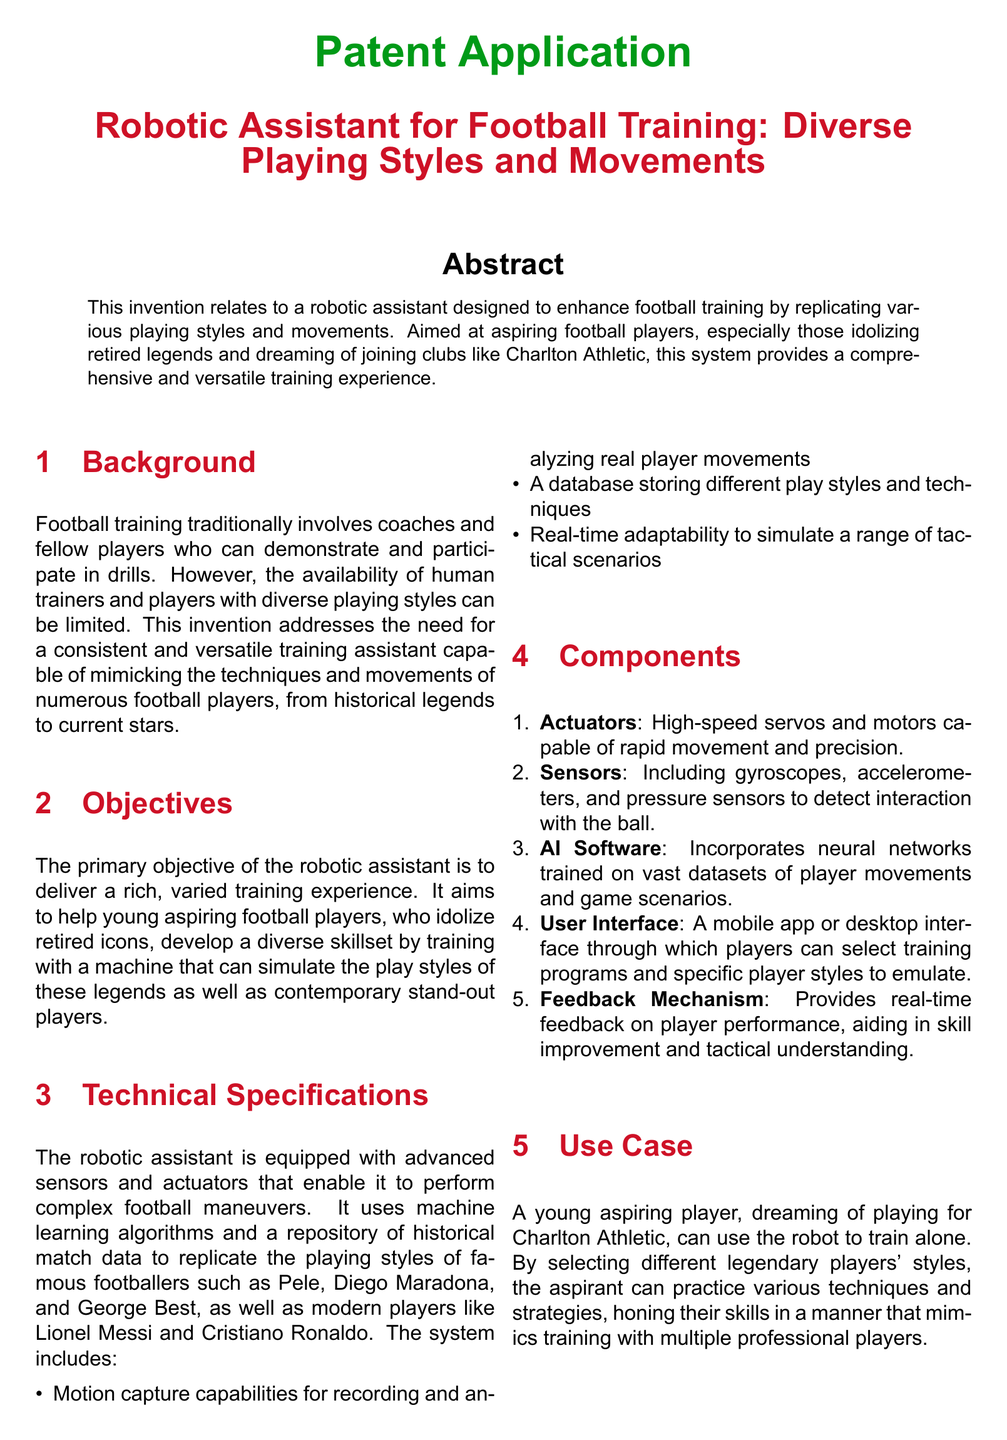what is the primary objective of the robotic assistant? The primary objective is to deliver a rich, varied training experience for aspiring football players.
Answer: rich, varied training experience which legends does the robotic assistant replicate? The robotic assistant replicates the techniques and movements of players such as Pele and Diego Maradona.
Answer: Pele and Diego Maradona what technology enables the robotic assistant to perform complex maneuvers? The robotic assistant uses advanced sensors and actuators to perform complex football maneuvers.
Answer: advanced sensors and actuators how does the user interface operate? The user interface operates through a mobile app or desktop interface for selecting training programs.
Answer: mobile app or desktop interface what is one key benefit of the robotic assistant? One key benefit is that it provides a constant training partner without variability.
Answer: constant training partner how does the feedback mechanism assist players? The feedback mechanism provides real-time feedback on player performance for skill improvement.
Answer: real-time feedback what type of analytics does the robotic assistant deliver? The robotic assistant delivers advanced analytics to help players improve.
Answer: advanced analytics how does the system adapt during training? The system adapts in real-time to simulate a range of tactical scenarios.
Answer: real-time adaptability 